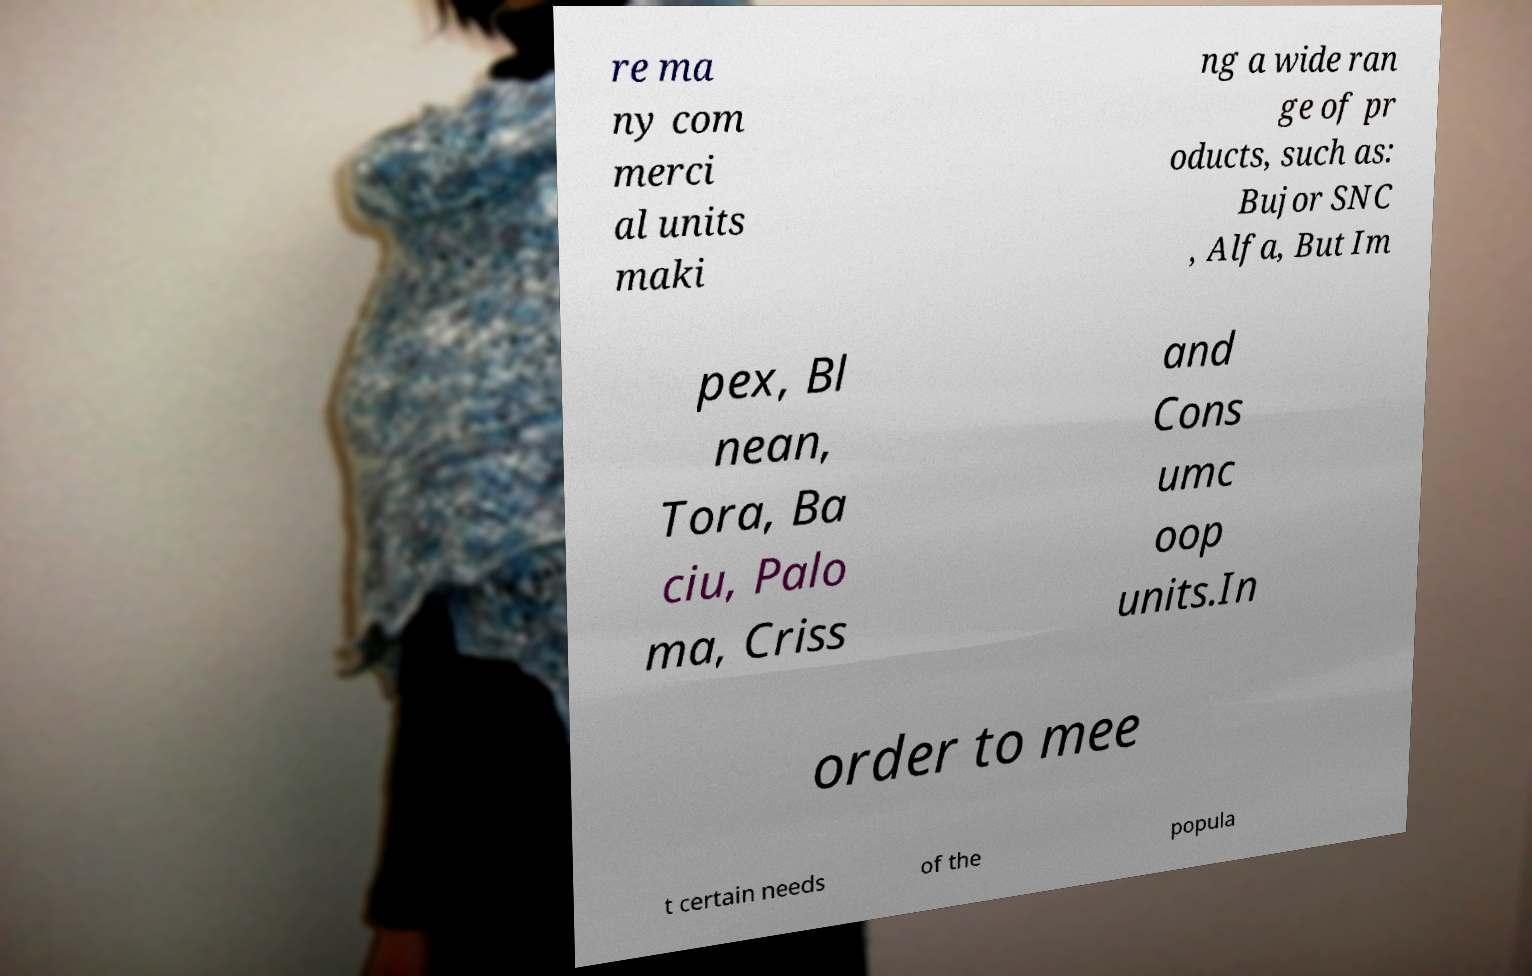Could you assist in decoding the text presented in this image and type it out clearly? re ma ny com merci al units maki ng a wide ran ge of pr oducts, such as: Bujor SNC , Alfa, But Im pex, Bl nean, Tora, Ba ciu, Palo ma, Criss and Cons umc oop units.In order to mee t certain needs of the popula 